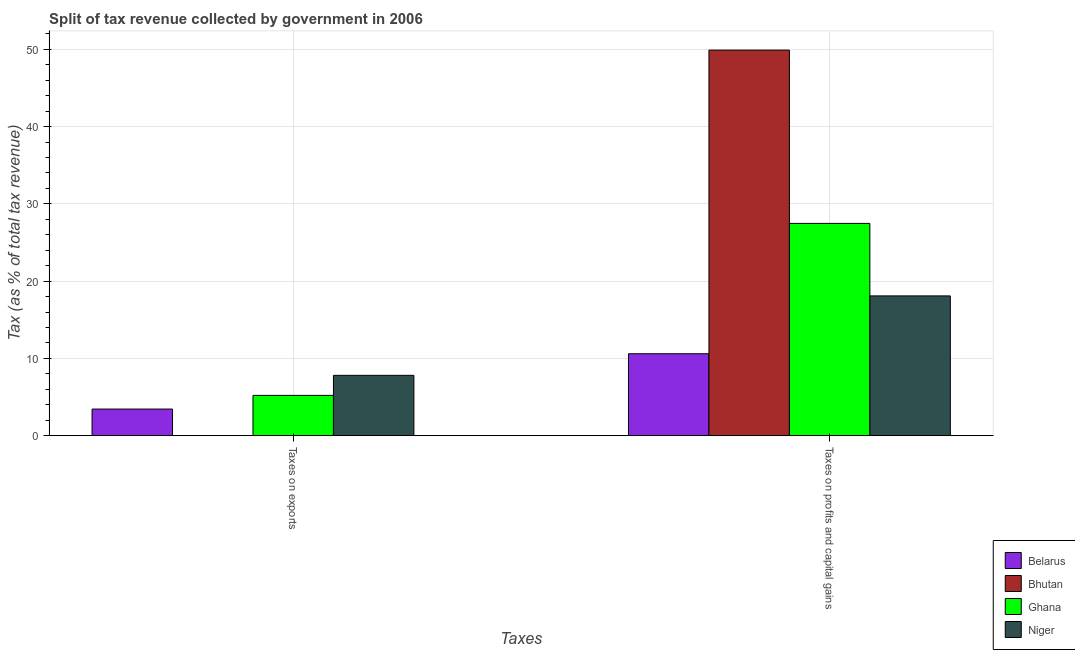How many groups of bars are there?
Provide a short and direct response. 2. Are the number of bars on each tick of the X-axis equal?
Keep it short and to the point. Yes. What is the label of the 1st group of bars from the left?
Offer a very short reply. Taxes on exports. What is the percentage of revenue obtained from taxes on exports in Ghana?
Offer a very short reply. 5.21. Across all countries, what is the maximum percentage of revenue obtained from taxes on exports?
Your answer should be compact. 7.81. Across all countries, what is the minimum percentage of revenue obtained from taxes on profits and capital gains?
Offer a terse response. 10.6. In which country was the percentage of revenue obtained from taxes on profits and capital gains maximum?
Your answer should be very brief. Bhutan. In which country was the percentage of revenue obtained from taxes on exports minimum?
Ensure brevity in your answer.  Bhutan. What is the total percentage of revenue obtained from taxes on profits and capital gains in the graph?
Make the answer very short. 106.07. What is the difference between the percentage of revenue obtained from taxes on exports in Ghana and that in Bhutan?
Your response must be concise. 5.2. What is the difference between the percentage of revenue obtained from taxes on profits and capital gains in Ghana and the percentage of revenue obtained from taxes on exports in Bhutan?
Ensure brevity in your answer.  27.47. What is the average percentage of revenue obtained from taxes on profits and capital gains per country?
Offer a terse response. 26.52. What is the difference between the percentage of revenue obtained from taxes on exports and percentage of revenue obtained from taxes on profits and capital gains in Bhutan?
Your response must be concise. -49.9. What is the ratio of the percentage of revenue obtained from taxes on profits and capital gains in Belarus to that in Bhutan?
Provide a short and direct response. 0.21. How many countries are there in the graph?
Keep it short and to the point. 4. Are the values on the major ticks of Y-axis written in scientific E-notation?
Keep it short and to the point. No. Does the graph contain any zero values?
Offer a very short reply. No. How many legend labels are there?
Provide a short and direct response. 4. How are the legend labels stacked?
Ensure brevity in your answer.  Vertical. What is the title of the graph?
Offer a very short reply. Split of tax revenue collected by government in 2006. What is the label or title of the X-axis?
Keep it short and to the point. Taxes. What is the label or title of the Y-axis?
Keep it short and to the point. Tax (as % of total tax revenue). What is the Tax (as % of total tax revenue) of Belarus in Taxes on exports?
Your answer should be very brief. 3.44. What is the Tax (as % of total tax revenue) of Bhutan in Taxes on exports?
Offer a terse response. 0.01. What is the Tax (as % of total tax revenue) of Ghana in Taxes on exports?
Give a very brief answer. 5.21. What is the Tax (as % of total tax revenue) in Niger in Taxes on exports?
Ensure brevity in your answer.  7.81. What is the Tax (as % of total tax revenue) of Belarus in Taxes on profits and capital gains?
Your answer should be very brief. 10.6. What is the Tax (as % of total tax revenue) in Bhutan in Taxes on profits and capital gains?
Give a very brief answer. 49.91. What is the Tax (as % of total tax revenue) in Ghana in Taxes on profits and capital gains?
Provide a short and direct response. 27.47. What is the Tax (as % of total tax revenue) in Niger in Taxes on profits and capital gains?
Ensure brevity in your answer.  18.09. Across all Taxes, what is the maximum Tax (as % of total tax revenue) of Belarus?
Offer a terse response. 10.6. Across all Taxes, what is the maximum Tax (as % of total tax revenue) of Bhutan?
Your answer should be compact. 49.91. Across all Taxes, what is the maximum Tax (as % of total tax revenue) in Ghana?
Provide a succinct answer. 27.47. Across all Taxes, what is the maximum Tax (as % of total tax revenue) in Niger?
Your answer should be very brief. 18.09. Across all Taxes, what is the minimum Tax (as % of total tax revenue) in Belarus?
Provide a succinct answer. 3.44. Across all Taxes, what is the minimum Tax (as % of total tax revenue) of Bhutan?
Offer a terse response. 0.01. Across all Taxes, what is the minimum Tax (as % of total tax revenue) in Ghana?
Keep it short and to the point. 5.21. Across all Taxes, what is the minimum Tax (as % of total tax revenue) in Niger?
Your answer should be compact. 7.81. What is the total Tax (as % of total tax revenue) in Belarus in the graph?
Offer a very short reply. 14.04. What is the total Tax (as % of total tax revenue) in Bhutan in the graph?
Provide a succinct answer. 49.92. What is the total Tax (as % of total tax revenue) of Ghana in the graph?
Make the answer very short. 32.69. What is the total Tax (as % of total tax revenue) in Niger in the graph?
Your response must be concise. 25.89. What is the difference between the Tax (as % of total tax revenue) in Belarus in Taxes on exports and that in Taxes on profits and capital gains?
Your answer should be very brief. -7.16. What is the difference between the Tax (as % of total tax revenue) of Bhutan in Taxes on exports and that in Taxes on profits and capital gains?
Ensure brevity in your answer.  -49.9. What is the difference between the Tax (as % of total tax revenue) of Ghana in Taxes on exports and that in Taxes on profits and capital gains?
Make the answer very short. -22.26. What is the difference between the Tax (as % of total tax revenue) of Niger in Taxes on exports and that in Taxes on profits and capital gains?
Ensure brevity in your answer.  -10.28. What is the difference between the Tax (as % of total tax revenue) of Belarus in Taxes on exports and the Tax (as % of total tax revenue) of Bhutan in Taxes on profits and capital gains?
Provide a succinct answer. -46.47. What is the difference between the Tax (as % of total tax revenue) of Belarus in Taxes on exports and the Tax (as % of total tax revenue) of Ghana in Taxes on profits and capital gains?
Ensure brevity in your answer.  -24.03. What is the difference between the Tax (as % of total tax revenue) in Belarus in Taxes on exports and the Tax (as % of total tax revenue) in Niger in Taxes on profits and capital gains?
Provide a succinct answer. -14.65. What is the difference between the Tax (as % of total tax revenue) of Bhutan in Taxes on exports and the Tax (as % of total tax revenue) of Ghana in Taxes on profits and capital gains?
Ensure brevity in your answer.  -27.47. What is the difference between the Tax (as % of total tax revenue) in Bhutan in Taxes on exports and the Tax (as % of total tax revenue) in Niger in Taxes on profits and capital gains?
Offer a terse response. -18.08. What is the difference between the Tax (as % of total tax revenue) of Ghana in Taxes on exports and the Tax (as % of total tax revenue) of Niger in Taxes on profits and capital gains?
Your response must be concise. -12.88. What is the average Tax (as % of total tax revenue) in Belarus per Taxes?
Provide a succinct answer. 7.02. What is the average Tax (as % of total tax revenue) of Bhutan per Taxes?
Offer a very short reply. 24.96. What is the average Tax (as % of total tax revenue) in Ghana per Taxes?
Offer a terse response. 16.34. What is the average Tax (as % of total tax revenue) in Niger per Taxes?
Your answer should be very brief. 12.95. What is the difference between the Tax (as % of total tax revenue) of Belarus and Tax (as % of total tax revenue) of Bhutan in Taxes on exports?
Keep it short and to the point. 3.43. What is the difference between the Tax (as % of total tax revenue) in Belarus and Tax (as % of total tax revenue) in Ghana in Taxes on exports?
Provide a short and direct response. -1.77. What is the difference between the Tax (as % of total tax revenue) of Belarus and Tax (as % of total tax revenue) of Niger in Taxes on exports?
Offer a terse response. -4.36. What is the difference between the Tax (as % of total tax revenue) in Bhutan and Tax (as % of total tax revenue) in Ghana in Taxes on exports?
Give a very brief answer. -5.2. What is the difference between the Tax (as % of total tax revenue) in Bhutan and Tax (as % of total tax revenue) in Niger in Taxes on exports?
Your answer should be very brief. -7.8. What is the difference between the Tax (as % of total tax revenue) in Ghana and Tax (as % of total tax revenue) in Niger in Taxes on exports?
Provide a short and direct response. -2.59. What is the difference between the Tax (as % of total tax revenue) of Belarus and Tax (as % of total tax revenue) of Bhutan in Taxes on profits and capital gains?
Your answer should be very brief. -39.31. What is the difference between the Tax (as % of total tax revenue) of Belarus and Tax (as % of total tax revenue) of Ghana in Taxes on profits and capital gains?
Ensure brevity in your answer.  -16.87. What is the difference between the Tax (as % of total tax revenue) in Belarus and Tax (as % of total tax revenue) in Niger in Taxes on profits and capital gains?
Give a very brief answer. -7.49. What is the difference between the Tax (as % of total tax revenue) in Bhutan and Tax (as % of total tax revenue) in Ghana in Taxes on profits and capital gains?
Offer a terse response. 22.43. What is the difference between the Tax (as % of total tax revenue) in Bhutan and Tax (as % of total tax revenue) in Niger in Taxes on profits and capital gains?
Your response must be concise. 31.82. What is the difference between the Tax (as % of total tax revenue) of Ghana and Tax (as % of total tax revenue) of Niger in Taxes on profits and capital gains?
Make the answer very short. 9.39. What is the ratio of the Tax (as % of total tax revenue) in Belarus in Taxes on exports to that in Taxes on profits and capital gains?
Your answer should be compact. 0.32. What is the ratio of the Tax (as % of total tax revenue) of Ghana in Taxes on exports to that in Taxes on profits and capital gains?
Provide a short and direct response. 0.19. What is the ratio of the Tax (as % of total tax revenue) of Niger in Taxes on exports to that in Taxes on profits and capital gains?
Your response must be concise. 0.43. What is the difference between the highest and the second highest Tax (as % of total tax revenue) in Belarus?
Give a very brief answer. 7.16. What is the difference between the highest and the second highest Tax (as % of total tax revenue) of Bhutan?
Provide a short and direct response. 49.9. What is the difference between the highest and the second highest Tax (as % of total tax revenue) of Ghana?
Keep it short and to the point. 22.26. What is the difference between the highest and the second highest Tax (as % of total tax revenue) of Niger?
Keep it short and to the point. 10.28. What is the difference between the highest and the lowest Tax (as % of total tax revenue) in Belarus?
Keep it short and to the point. 7.16. What is the difference between the highest and the lowest Tax (as % of total tax revenue) in Bhutan?
Provide a succinct answer. 49.9. What is the difference between the highest and the lowest Tax (as % of total tax revenue) in Ghana?
Make the answer very short. 22.26. What is the difference between the highest and the lowest Tax (as % of total tax revenue) in Niger?
Offer a terse response. 10.28. 